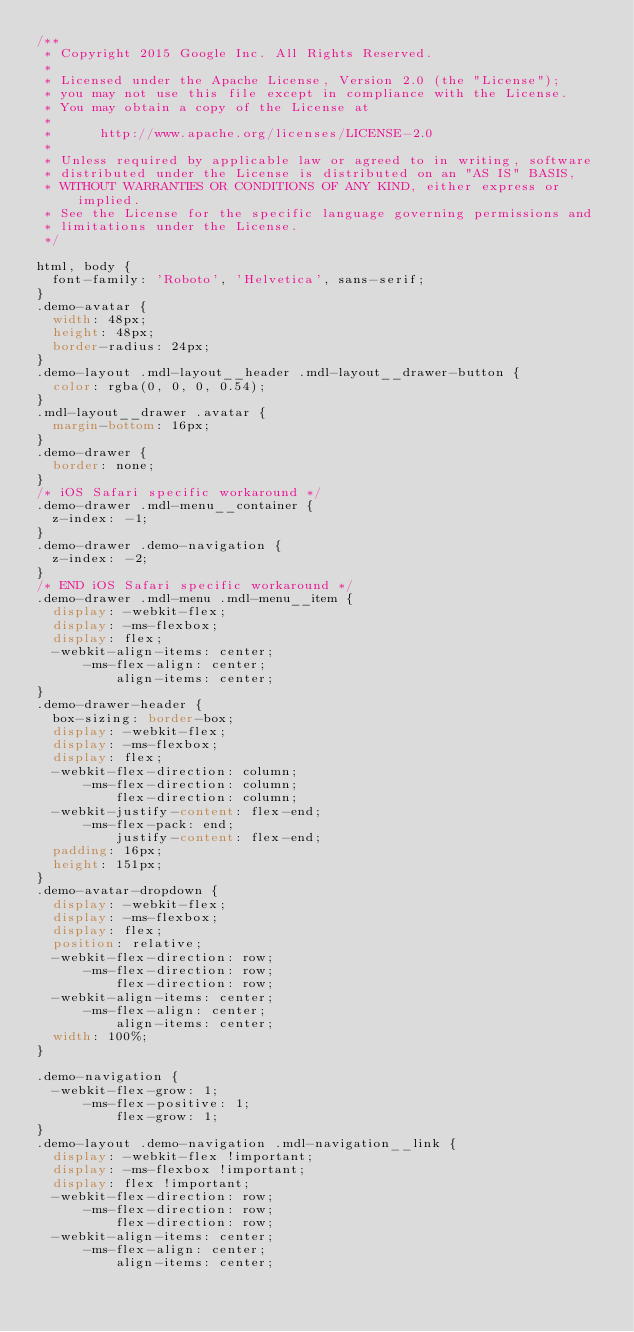<code> <loc_0><loc_0><loc_500><loc_500><_CSS_>/**
 * Copyright 2015 Google Inc. All Rights Reserved.
 *
 * Licensed under the Apache License, Version 2.0 (the "License");
 * you may not use this file except in compliance with the License.
 * You may obtain a copy of the License at
 *
 *      http://www.apache.org/licenses/LICENSE-2.0
 *
 * Unless required by applicable law or agreed to in writing, software
 * distributed under the License is distributed on an "AS IS" BASIS,
 * WITHOUT WARRANTIES OR CONDITIONS OF ANY KIND, either express or implied.
 * See the License for the specific language governing permissions and
 * limitations under the License.
 */

html, body {
  font-family: 'Roboto', 'Helvetica', sans-serif;
}
.demo-avatar {
  width: 48px;
  height: 48px;
  border-radius: 24px;
}
.demo-layout .mdl-layout__header .mdl-layout__drawer-button {
  color: rgba(0, 0, 0, 0.54);
}
.mdl-layout__drawer .avatar {
  margin-bottom: 16px;
}
.demo-drawer {
  border: none;
}
/* iOS Safari specific workaround */
.demo-drawer .mdl-menu__container {
  z-index: -1;
}
.demo-drawer .demo-navigation {
  z-index: -2;
}
/* END iOS Safari specific workaround */
.demo-drawer .mdl-menu .mdl-menu__item {
  display: -webkit-flex;
  display: -ms-flexbox;
  display: flex;
  -webkit-align-items: center;
      -ms-flex-align: center;
          align-items: center;
}
.demo-drawer-header {
  box-sizing: border-box;
  display: -webkit-flex;
  display: -ms-flexbox;
  display: flex;
  -webkit-flex-direction: column;
      -ms-flex-direction: column;
          flex-direction: column;
  -webkit-justify-content: flex-end;
      -ms-flex-pack: end;
          justify-content: flex-end;
  padding: 16px;
  height: 151px;
}
.demo-avatar-dropdown {
  display: -webkit-flex;
  display: -ms-flexbox;
  display: flex;
  position: relative;
  -webkit-flex-direction: row;
      -ms-flex-direction: row;
          flex-direction: row;
  -webkit-align-items: center;
      -ms-flex-align: center;
          align-items: center;
  width: 100%;
}

.demo-navigation {
  -webkit-flex-grow: 1;
      -ms-flex-positive: 1;
          flex-grow: 1;
}
.demo-layout .demo-navigation .mdl-navigation__link {
  display: -webkit-flex !important;
  display: -ms-flexbox !important;
  display: flex !important;
  -webkit-flex-direction: row;
      -ms-flex-direction: row;
          flex-direction: row;
  -webkit-align-items: center;
      -ms-flex-align: center;
          align-items: center;</code> 